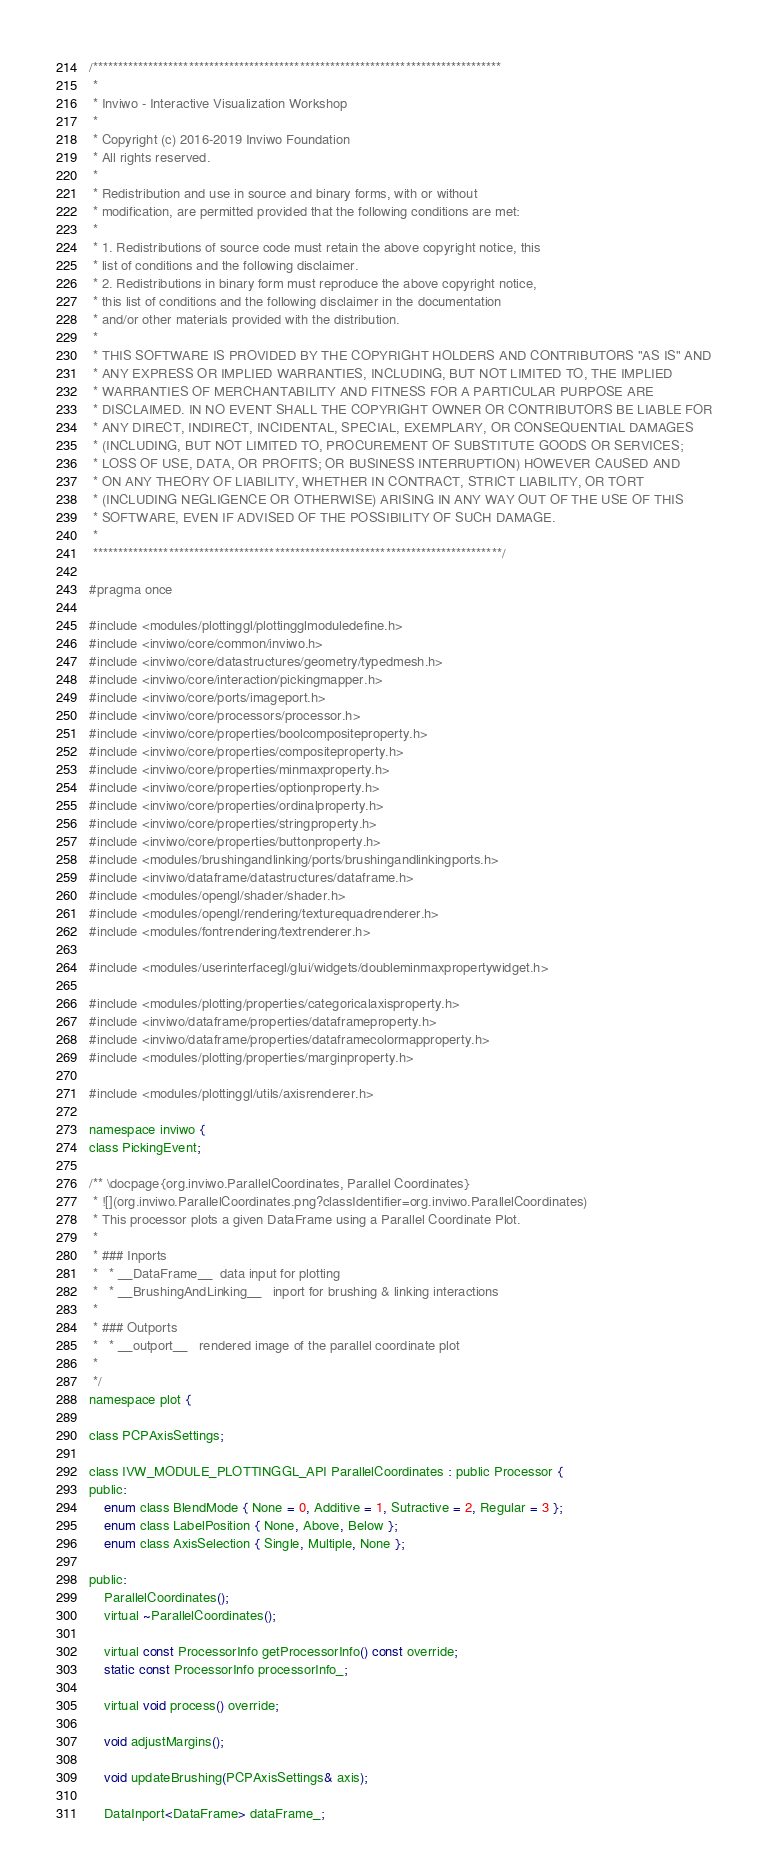Convert code to text. <code><loc_0><loc_0><loc_500><loc_500><_C_>/*********************************************************************************
 *
 * Inviwo - Interactive Visualization Workshop
 *
 * Copyright (c) 2016-2019 Inviwo Foundation
 * All rights reserved.
 *
 * Redistribution and use in source and binary forms, with or without
 * modification, are permitted provided that the following conditions are met:
 *
 * 1. Redistributions of source code must retain the above copyright notice, this
 * list of conditions and the following disclaimer.
 * 2. Redistributions in binary form must reproduce the above copyright notice,
 * this list of conditions and the following disclaimer in the documentation
 * and/or other materials provided with the distribution.
 *
 * THIS SOFTWARE IS PROVIDED BY THE COPYRIGHT HOLDERS AND CONTRIBUTORS "AS IS" AND
 * ANY EXPRESS OR IMPLIED WARRANTIES, INCLUDING, BUT NOT LIMITED TO, THE IMPLIED
 * WARRANTIES OF MERCHANTABILITY AND FITNESS FOR A PARTICULAR PURPOSE ARE
 * DISCLAIMED. IN NO EVENT SHALL THE COPYRIGHT OWNER OR CONTRIBUTORS BE LIABLE FOR
 * ANY DIRECT, INDIRECT, INCIDENTAL, SPECIAL, EXEMPLARY, OR CONSEQUENTIAL DAMAGES
 * (INCLUDING, BUT NOT LIMITED TO, PROCUREMENT OF SUBSTITUTE GOODS OR SERVICES;
 * LOSS OF USE, DATA, OR PROFITS; OR BUSINESS INTERRUPTION) HOWEVER CAUSED AND
 * ON ANY THEORY OF LIABILITY, WHETHER IN CONTRACT, STRICT LIABILITY, OR TORT
 * (INCLUDING NEGLIGENCE OR OTHERWISE) ARISING IN ANY WAY OUT OF THE USE OF THIS
 * SOFTWARE, EVEN IF ADVISED OF THE POSSIBILITY OF SUCH DAMAGE.
 *
 *********************************************************************************/

#pragma once

#include <modules/plottinggl/plottingglmoduledefine.h>
#include <inviwo/core/common/inviwo.h>
#include <inviwo/core/datastructures/geometry/typedmesh.h>
#include <inviwo/core/interaction/pickingmapper.h>
#include <inviwo/core/ports/imageport.h>
#include <inviwo/core/processors/processor.h>
#include <inviwo/core/properties/boolcompositeproperty.h>
#include <inviwo/core/properties/compositeproperty.h>
#include <inviwo/core/properties/minmaxproperty.h>
#include <inviwo/core/properties/optionproperty.h>
#include <inviwo/core/properties/ordinalproperty.h>
#include <inviwo/core/properties/stringproperty.h>
#include <inviwo/core/properties/buttonproperty.h>
#include <modules/brushingandlinking/ports/brushingandlinkingports.h>
#include <inviwo/dataframe/datastructures/dataframe.h>
#include <modules/opengl/shader/shader.h>
#include <modules/opengl/rendering/texturequadrenderer.h>
#include <modules/fontrendering/textrenderer.h>

#include <modules/userinterfacegl/glui/widgets/doubleminmaxpropertywidget.h>

#include <modules/plotting/properties/categoricalaxisproperty.h>
#include <inviwo/dataframe/properties/dataframeproperty.h>
#include <inviwo/dataframe/properties/dataframecolormapproperty.h>
#include <modules/plotting/properties/marginproperty.h>

#include <modules/plottinggl/utils/axisrenderer.h>

namespace inviwo {
class PickingEvent;

/** \docpage{org.inviwo.ParallelCoordinates, Parallel Coordinates}
 * ![](org.inviwo.ParallelCoordinates.png?classIdentifier=org.inviwo.ParallelCoordinates)
 * This processor plots a given DataFrame using a Parallel Coordinate Plot.
 *
 * ### Inports
 *   * __DataFrame__  data input for plotting
 *   * __BrushingAndLinking__   inport for brushing & linking interactions
 *
 * ### Outports
 *   * __outport__   rendered image of the parallel coordinate plot
 *
 */
namespace plot {

class PCPAxisSettings;

class IVW_MODULE_PLOTTINGGL_API ParallelCoordinates : public Processor {
public:
    enum class BlendMode { None = 0, Additive = 1, Sutractive = 2, Regular = 3 };
    enum class LabelPosition { None, Above, Below };
    enum class AxisSelection { Single, Multiple, None };

public:
    ParallelCoordinates();
    virtual ~ParallelCoordinates();

    virtual const ProcessorInfo getProcessorInfo() const override;
    static const ProcessorInfo processorInfo_;

    virtual void process() override;

    void adjustMargins();

    void updateBrushing(PCPAxisSettings& axis);

    DataInport<DataFrame> dataFrame_;</code> 